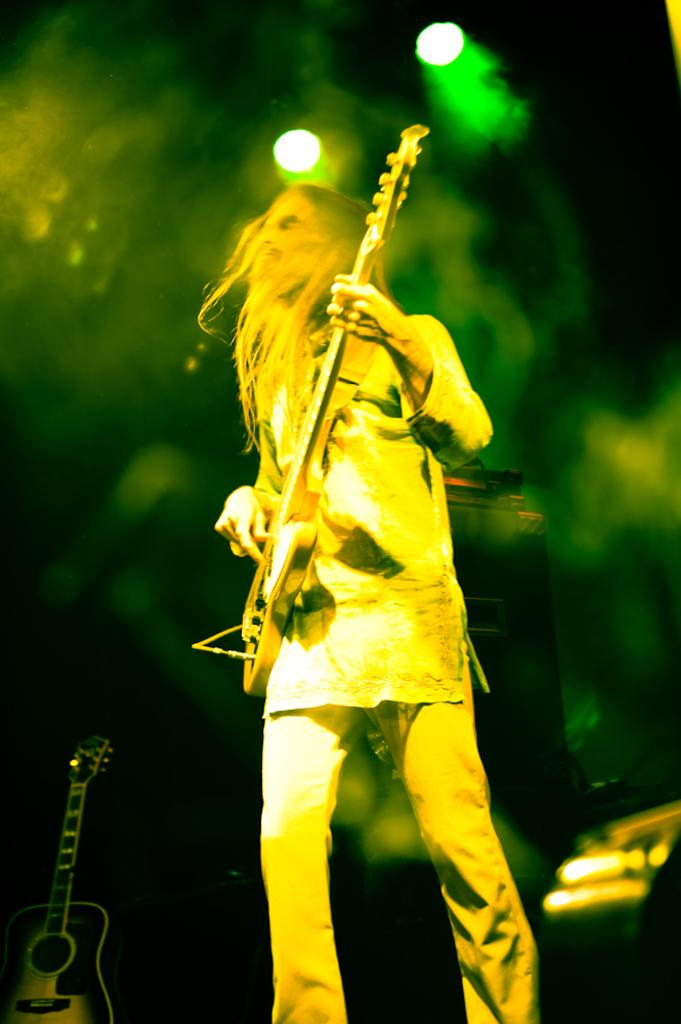What is the person in the image doing? The person is playing a guitar. What can be seen in the background of the image? There is smoke and lights in the background of the image. What else is present in the background of the image? There are musical instruments in the background of the image. What type of trade is being conducted in the image? There is no indication of any trade being conducted in the image; it features a person playing a guitar with a background of smoke, lights, and musical instruments. How many feet can be seen in the image? There is no visible foot or feet in the image. 